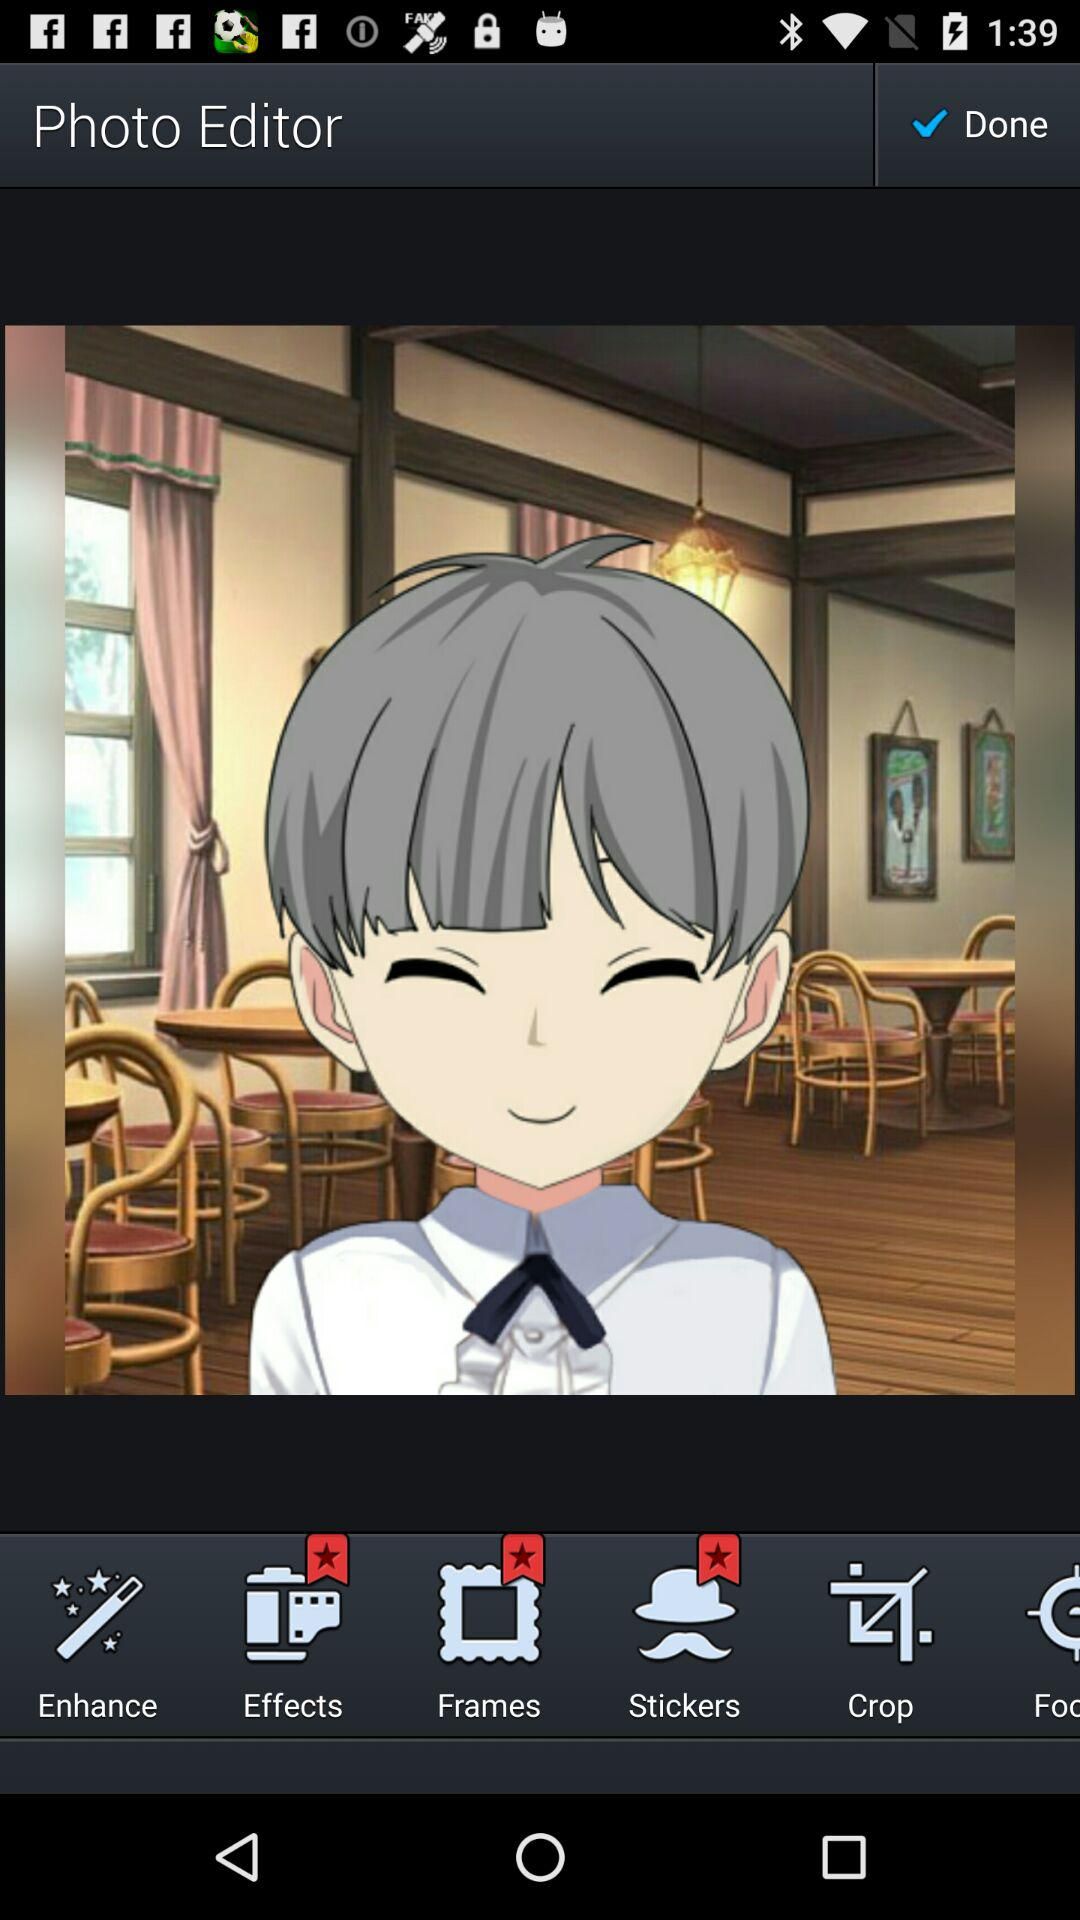What is the name of the application? The name of the application is "Photo Editor". 